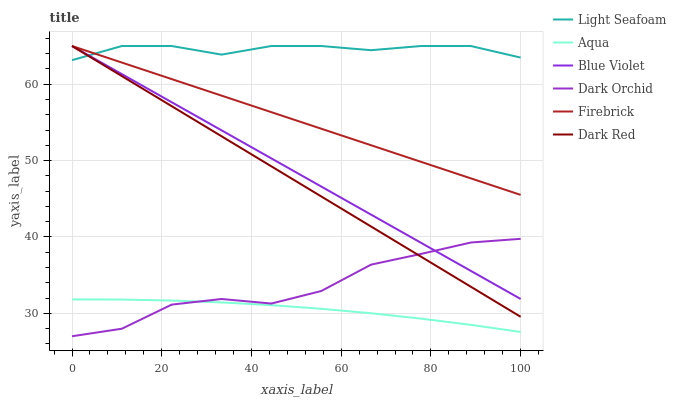Does Aqua have the minimum area under the curve?
Answer yes or no. Yes. Does Light Seafoam have the maximum area under the curve?
Answer yes or no. Yes. Does Firebrick have the minimum area under the curve?
Answer yes or no. No. Does Firebrick have the maximum area under the curve?
Answer yes or no. No. Is Firebrick the smoothest?
Answer yes or no. Yes. Is Dark Orchid the roughest?
Answer yes or no. Yes. Is Aqua the smoothest?
Answer yes or no. No. Is Aqua the roughest?
Answer yes or no. No. Does Dark Orchid have the lowest value?
Answer yes or no. Yes. Does Firebrick have the lowest value?
Answer yes or no. No. Does Blue Violet have the highest value?
Answer yes or no. Yes. Does Aqua have the highest value?
Answer yes or no. No. Is Aqua less than Firebrick?
Answer yes or no. Yes. Is Firebrick greater than Dark Orchid?
Answer yes or no. Yes. Does Blue Violet intersect Dark Red?
Answer yes or no. Yes. Is Blue Violet less than Dark Red?
Answer yes or no. No. Is Blue Violet greater than Dark Red?
Answer yes or no. No. Does Aqua intersect Firebrick?
Answer yes or no. No. 